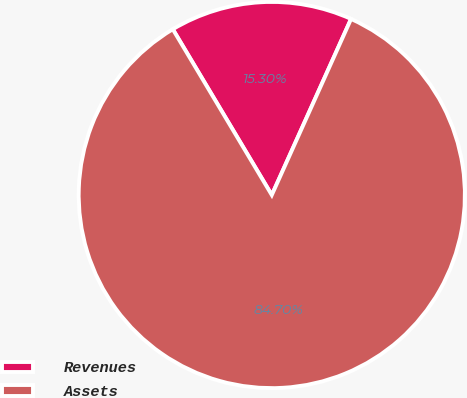Convert chart to OTSL. <chart><loc_0><loc_0><loc_500><loc_500><pie_chart><fcel>Revenues<fcel>Assets<nl><fcel>15.3%<fcel>84.7%<nl></chart> 